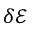Convert formula to latex. <formula><loc_0><loc_0><loc_500><loc_500>\delta { { \mathcal { E } } }</formula> 